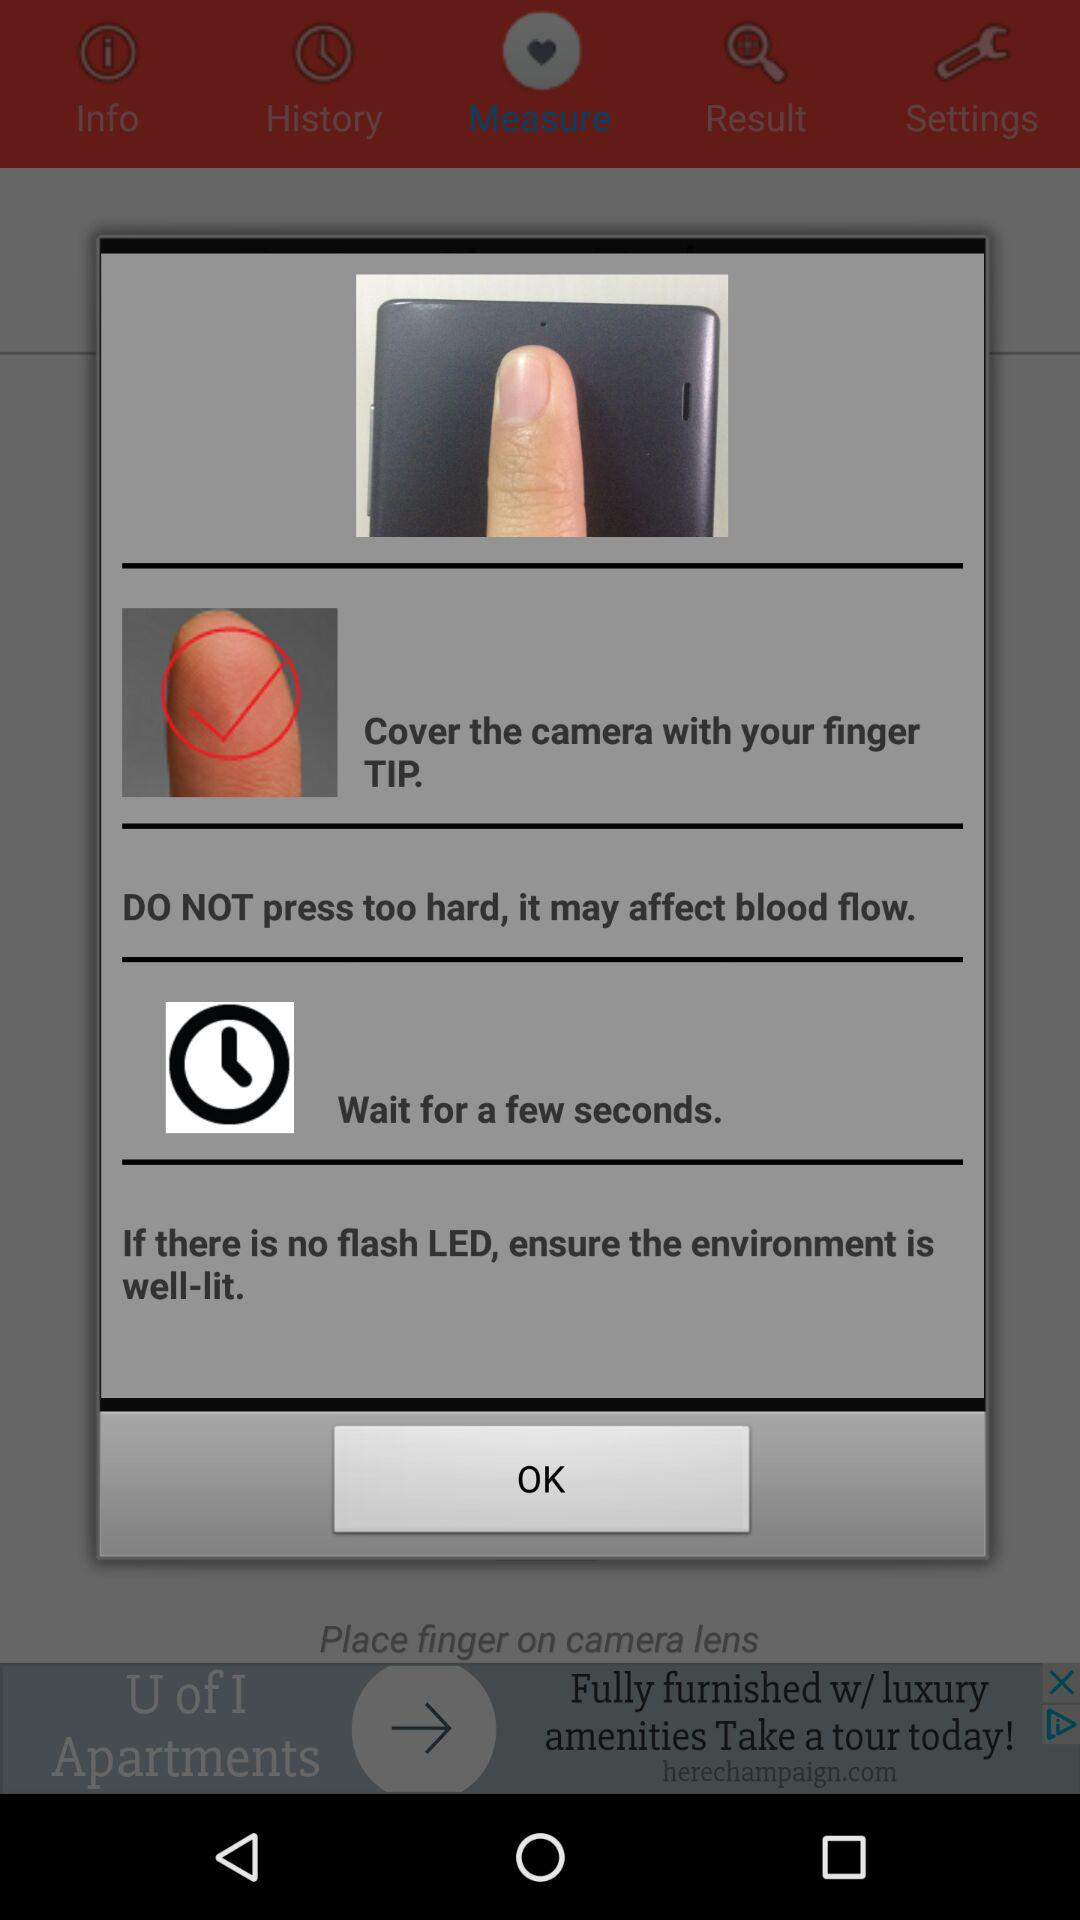Which tab is selected? The selected tab is "Measure". 